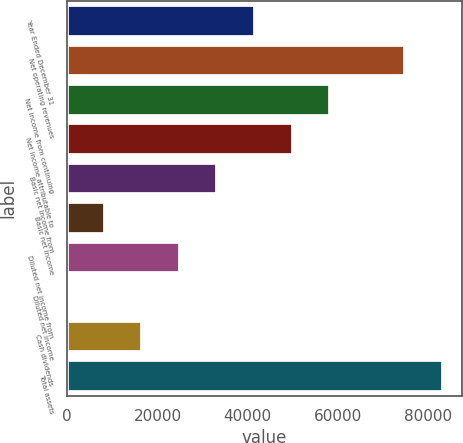Convert chart to OTSL. <chart><loc_0><loc_0><loc_500><loc_500><bar_chart><fcel>Year Ended December 31<fcel>Net operating revenues<fcel>Net income from continuing<fcel>Net income attributable to<fcel>Basic net income from<fcel>Basic net income<fcel>Diluted net income from<fcel>Diluted net income<fcel>Cash dividends<fcel>Total assets<nl><fcel>41608.8<fcel>74894.6<fcel>58251.7<fcel>49930.2<fcel>33287.3<fcel>8322.95<fcel>24965.8<fcel>1.5<fcel>16644.4<fcel>83216<nl></chart> 